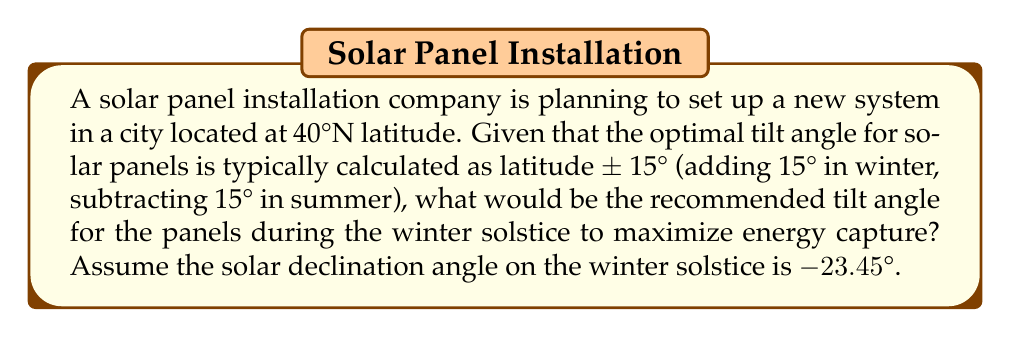Help me with this question. To calculate the optimal tilt angle for solar panels during the winter solstice, we'll follow these steps:

1. Recall the general rule for optimal tilt angle:
   Winter tilt angle = Latitude + 15°

2. Given information:
   - Latitude = 40°N
   - Winter solstice solar declination angle = -23.45°

3. Calculate the initial winter tilt angle:
   $$\text{Initial Winter Tilt Angle} = 40° + 15° = 55°$$

4. However, we can refine this calculation by considering the solar declination angle on the winter solstice. The optimal tilt angle should be perpendicular to the incoming solar radiation. We can calculate this using the formula:

   $$\text{Optimal Tilt Angle} = 90° - \text{Latitude} + \text{Solar Declination Angle}$$

5. Substituting the values:
   $$\text{Optimal Tilt Angle} = 90° - 40° + (-23.45°) = 26.55°$$

6. The final recommended tilt angle will be the larger of the two calculated angles, as this will ensure better performance during the shorter winter days:

   $$\text{Recommended Tilt Angle} = \max(55°, 26.55°) = 55°$$

Therefore, the recommended tilt angle for the solar panels during the winter solstice is 55°.

[asy]
import geometry;

size(200);
draw((-100,0)--(100,0),arrow=Arrow(TeXHead));
draw((0,-50)--(0,100),arrow=Arrow(TeXHead));
draw((0,0)--(70,70),arrow=Arrow(TeXHead));
draw((70,0)--(70,70),dashed);
draw((0,0)--(70,0),dashed);

label("Ground", (50,-10));
label("Solar Panel", (80,40), E);
label("55°", (20,20), NW);
label("Sun's rays", (35,80), N);

dot((0,0));
[/asy]
Answer: 55° 